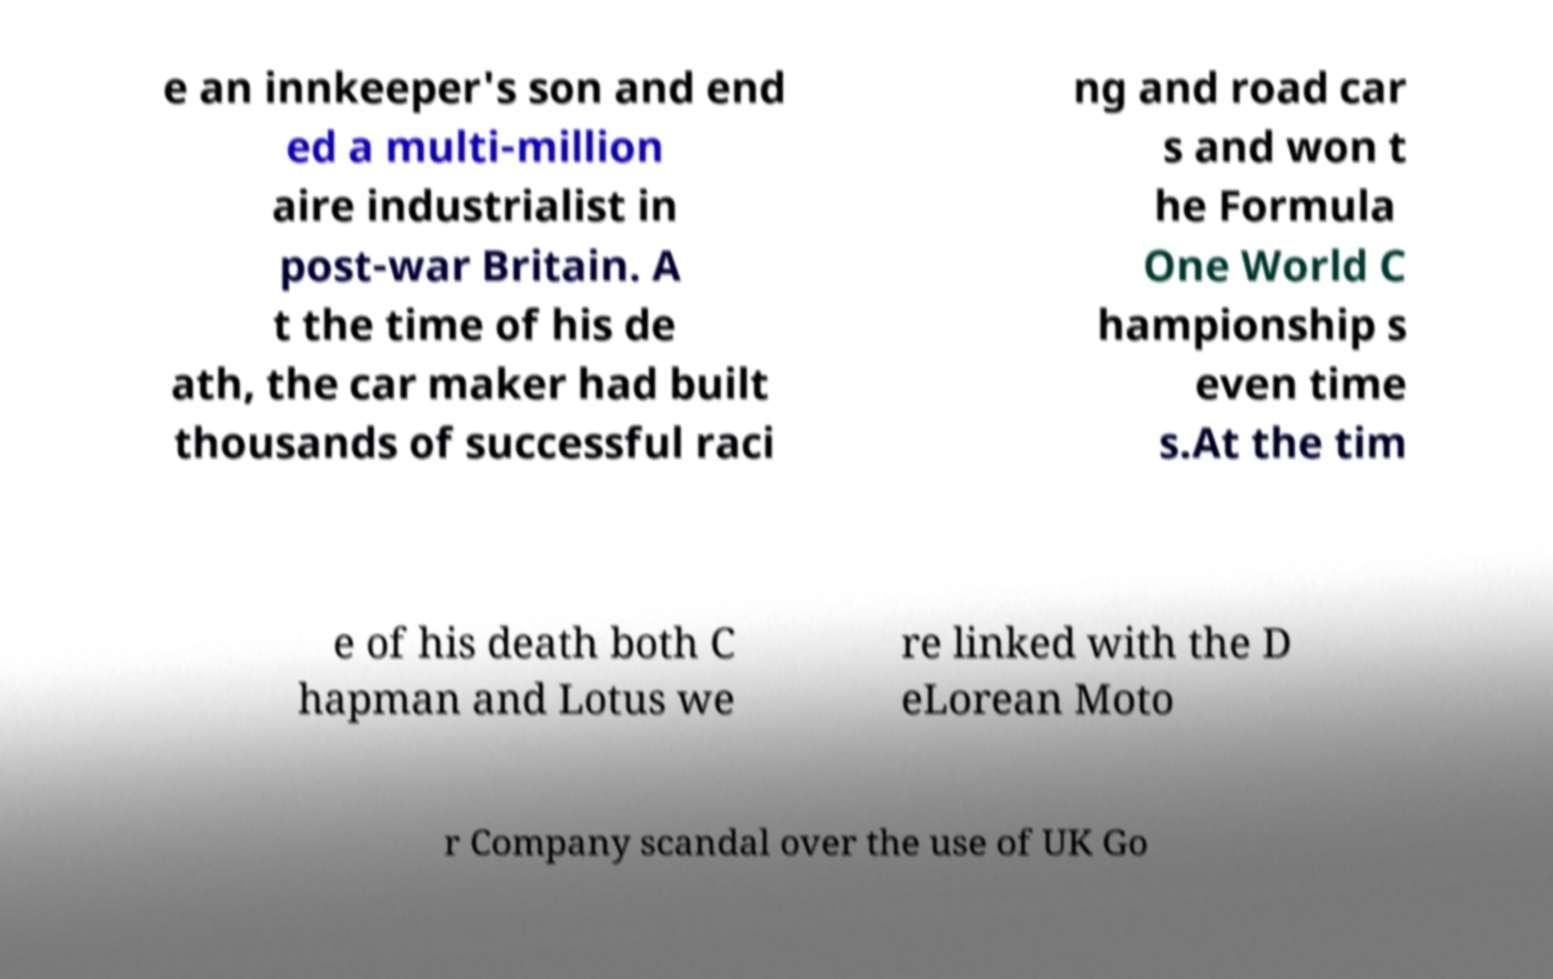Could you extract and type out the text from this image? e an innkeeper's son and end ed a multi-million aire industrialist in post-war Britain. A t the time of his de ath, the car maker had built thousands of successful raci ng and road car s and won t he Formula One World C hampionship s even time s.At the tim e of his death both C hapman and Lotus we re linked with the D eLorean Moto r Company scandal over the use of UK Go 